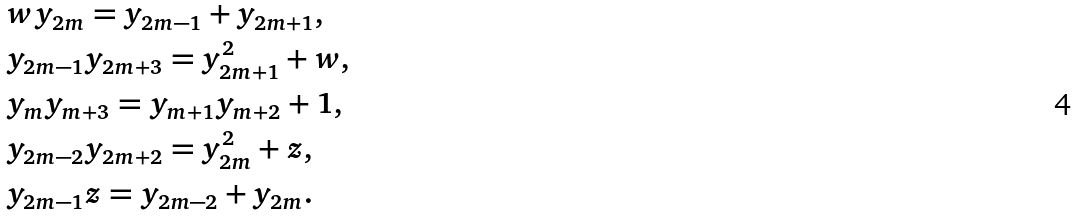<formula> <loc_0><loc_0><loc_500><loc_500>& w y _ { 2 m } = y _ { 2 m - 1 } + y _ { 2 m + 1 } , \\ & y _ { 2 m - 1 } y _ { 2 m + 3 } = y ^ { 2 } _ { 2 m + 1 } + w , \\ & y _ { m } y _ { m + 3 } = y _ { m + 1 } y _ { m + 2 } + 1 , \\ & y _ { 2 m - 2 } y _ { 2 m + 2 } = y ^ { 2 } _ { 2 m } + z , \\ & y _ { 2 m - 1 } z = y _ { 2 m - 2 } + y _ { 2 m } .</formula> 